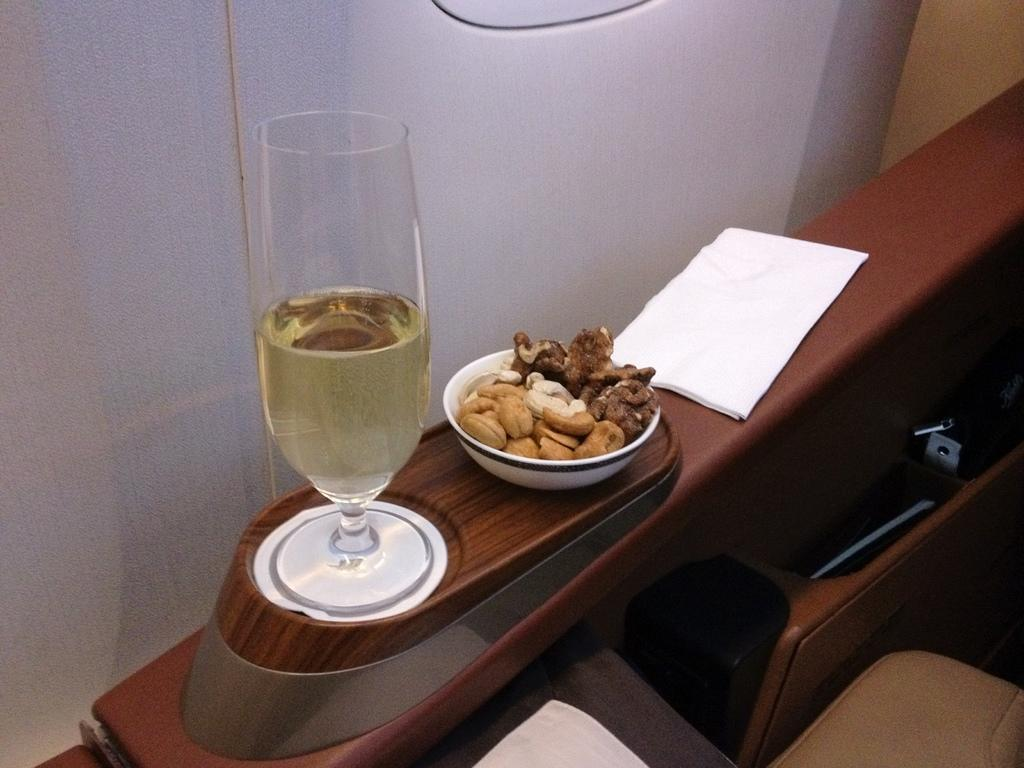What is attached to the chair in the image? There is a glass and a bowl with dry fruits on the chair handle. What else is on the chair handle? There is also a paper on the chair handle. What can be seen in the background of the image? There is a wall visible in the background of the image. What type of cheese is being played on the guitar at the airport in the image? There is no cheese, guitar, or airport present in the image. 